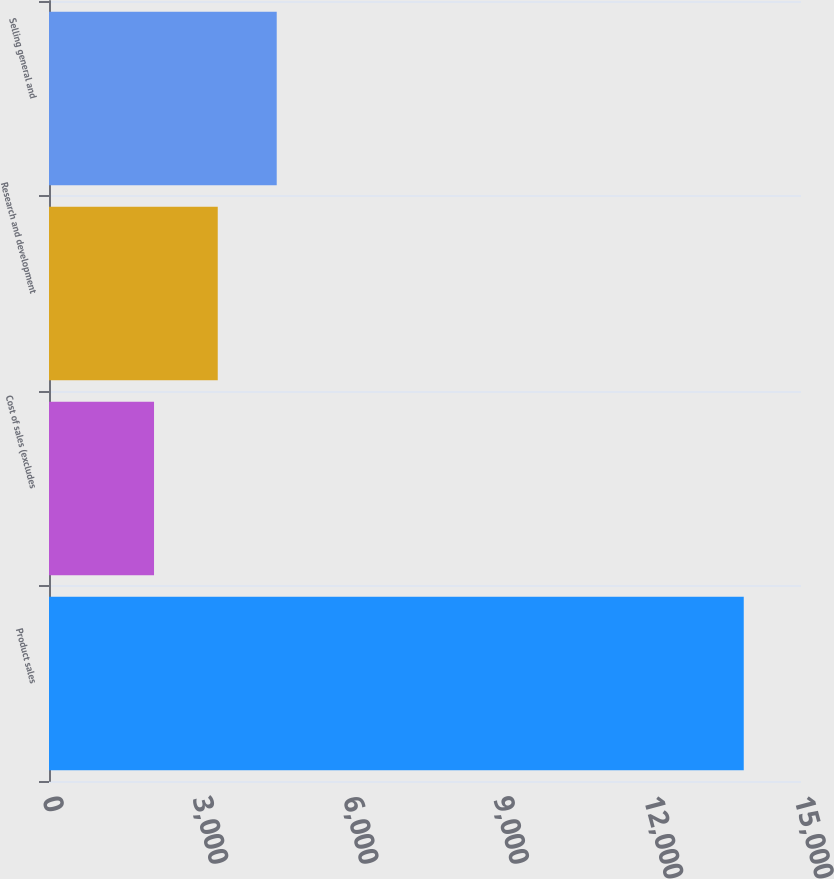Convert chart. <chart><loc_0><loc_0><loc_500><loc_500><bar_chart><fcel>Product sales<fcel>Cost of sales (excludes<fcel>Research and development<fcel>Selling general and<nl><fcel>13858<fcel>2095<fcel>3366<fcel>4542.3<nl></chart> 